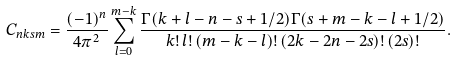Convert formula to latex. <formula><loc_0><loc_0><loc_500><loc_500>C _ { n k s m } = \frac { ( - 1 ) ^ { n } } { 4 \pi ^ { 2 } } \sum _ { l = 0 } ^ { m - k } \frac { \Gamma ( k + l - n - s + 1 / 2 ) \Gamma ( s + m - k - l + 1 / 2 ) } { k ! \, l ! \, ( m - k - l ) ! \, ( 2 k - 2 n - 2 s ) ! \, ( 2 s ) ! } .</formula> 